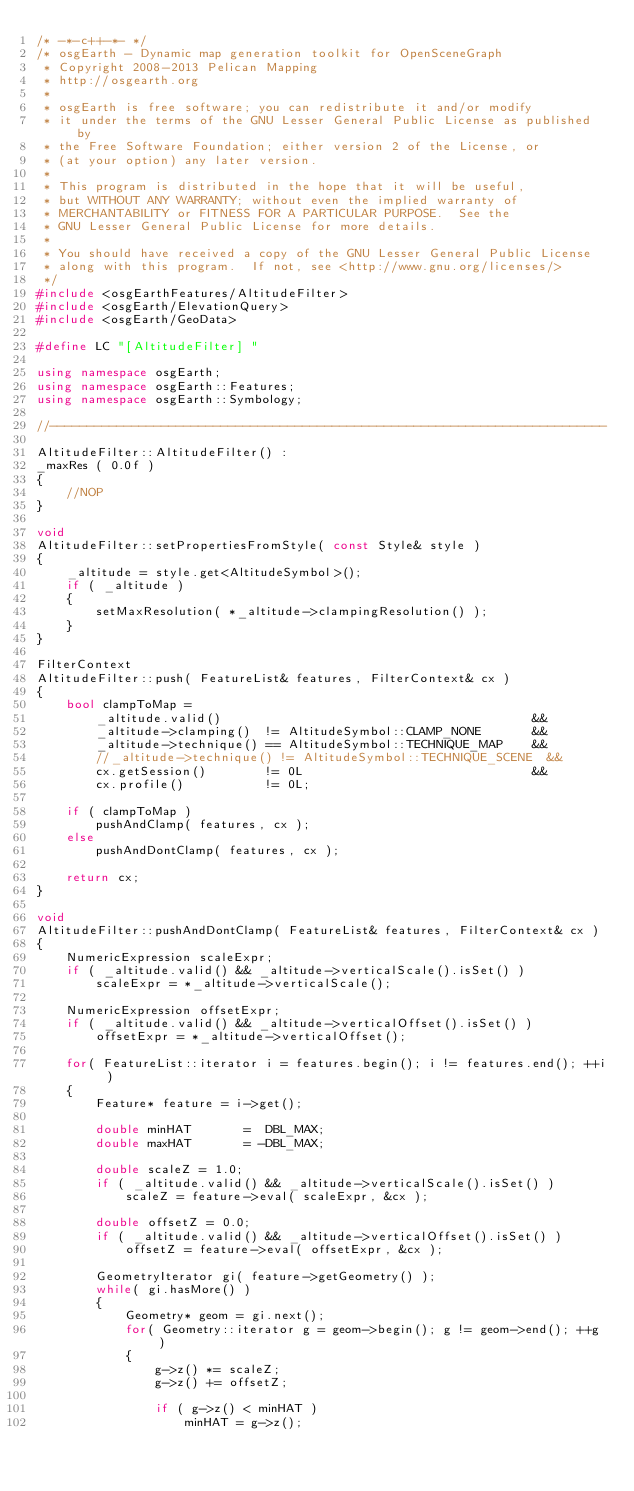Convert code to text. <code><loc_0><loc_0><loc_500><loc_500><_C++_>/* -*-c++-*- */
/* osgEarth - Dynamic map generation toolkit for OpenSceneGraph
 * Copyright 2008-2013 Pelican Mapping
 * http://osgearth.org
 *
 * osgEarth is free software; you can redistribute it and/or modify
 * it under the terms of the GNU Lesser General Public License as published by
 * the Free Software Foundation; either version 2 of the License, or
 * (at your option) any later version.
 *
 * This program is distributed in the hope that it will be useful,
 * but WITHOUT ANY WARRANTY; without even the implied warranty of
 * MERCHANTABILITY or FITNESS FOR A PARTICULAR PURPOSE.  See the
 * GNU Lesser General Public License for more details.
 *
 * You should have received a copy of the GNU Lesser General Public License
 * along with this program.  If not, see <http://www.gnu.org/licenses/>
 */
#include <osgEarthFeatures/AltitudeFilter>
#include <osgEarth/ElevationQuery>
#include <osgEarth/GeoData>

#define LC "[AltitudeFilter] "

using namespace osgEarth;
using namespace osgEarth::Features;
using namespace osgEarth::Symbology;

//---------------------------------------------------------------------------

AltitudeFilter::AltitudeFilter() :
_maxRes ( 0.0f )
{
    //NOP
}

void
AltitudeFilter::setPropertiesFromStyle( const Style& style )
{
    _altitude = style.get<AltitudeSymbol>();
    if ( _altitude )
    {
        setMaxResolution( *_altitude->clampingResolution() );
    }
}

FilterContext
AltitudeFilter::push( FeatureList& features, FilterContext& cx )
{
    bool clampToMap = 
        _altitude.valid()                                          && 
        _altitude->clamping()  != AltitudeSymbol::CLAMP_NONE       &&
        _altitude->technique() == AltitudeSymbol::TECHNIQUE_MAP    &&
        //_altitude->technique() != AltitudeSymbol::TECHNIQUE_SCENE  &&
        cx.getSession()        != 0L                               &&
        cx.profile()           != 0L;

    if ( clampToMap )
        pushAndClamp( features, cx );
    else
        pushAndDontClamp( features, cx );

    return cx;
}

void
AltitudeFilter::pushAndDontClamp( FeatureList& features, FilterContext& cx )
{
    NumericExpression scaleExpr;
    if ( _altitude.valid() && _altitude->verticalScale().isSet() )
        scaleExpr = *_altitude->verticalScale();

    NumericExpression offsetExpr;
    if ( _altitude.valid() && _altitude->verticalOffset().isSet() )
        offsetExpr = *_altitude->verticalOffset();

    for( FeatureList::iterator i = features.begin(); i != features.end(); ++i )
    {
        Feature* feature = i->get();

        double minHAT       =  DBL_MAX;
        double maxHAT       = -DBL_MAX;

        double scaleZ = 1.0;
        if ( _altitude.valid() && _altitude->verticalScale().isSet() )
            scaleZ = feature->eval( scaleExpr, &cx );

        double offsetZ = 0.0;
        if ( _altitude.valid() && _altitude->verticalOffset().isSet() )
            offsetZ = feature->eval( offsetExpr, &cx );
        
        GeometryIterator gi( feature->getGeometry() );
        while( gi.hasMore() )
        {
            Geometry* geom = gi.next();
            for( Geometry::iterator g = geom->begin(); g != geom->end(); ++g )
            {
                g->z() *= scaleZ;
                g->z() += offsetZ;

                if ( g->z() < minHAT )
                    minHAT = g->z();</code> 